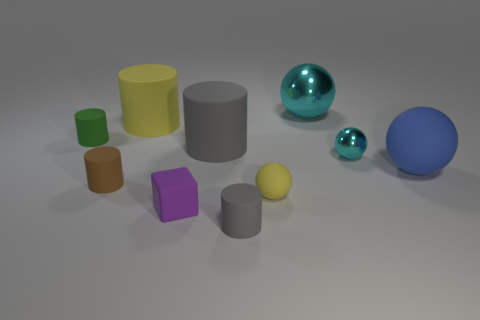How are the shadows in the image helping to understand the position of the light source? The shadows in the image are being cast mostly to the right and slightly forward, indicating that the light source is to the left, above, and slightly behind the objects. The length and direction of the shadows help determine the angle at which the light is hitting the objects. 